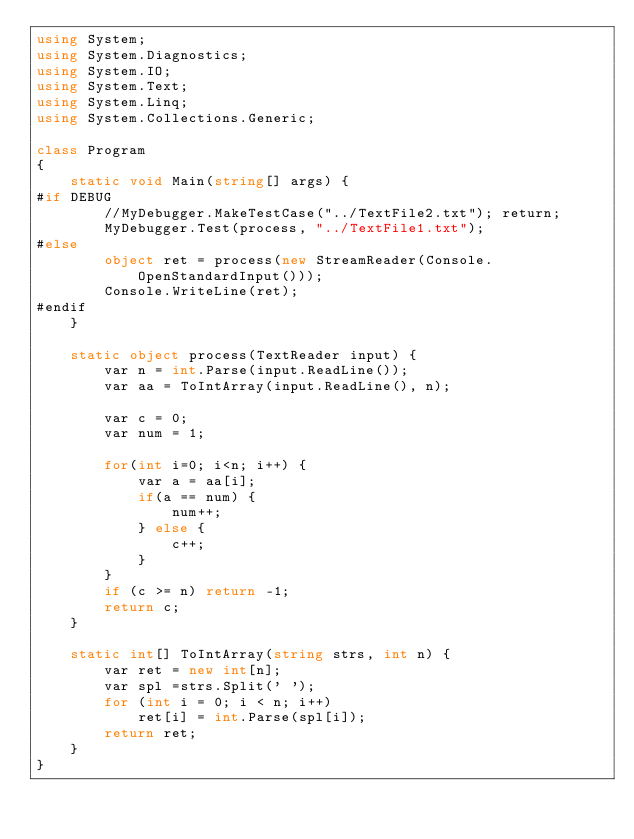<code> <loc_0><loc_0><loc_500><loc_500><_C#_>using System;
using System.Diagnostics;
using System.IO;
using System.Text;
using System.Linq;
using System.Collections.Generic;

class Program
{
    static void Main(string[] args) {
#if DEBUG
        //MyDebugger.MakeTestCase("../TextFile2.txt"); return;
        MyDebugger.Test(process, "../TextFile1.txt");
#else
        object ret = process(new StreamReader(Console.OpenStandardInput()));
        Console.WriteLine(ret);
#endif
    }

    static object process(TextReader input) {
        var n = int.Parse(input.ReadLine());
        var aa = ToIntArray(input.ReadLine(), n);

        var c = 0;
        var num = 1;

        for(int i=0; i<n; i++) {
            var a = aa[i];
            if(a == num) {
                num++;
            } else {
                c++;
            }
        }
        if (c >= n) return -1;
        return c;
    }

    static int[] ToIntArray(string strs, int n) {
        var ret = new int[n];
        var spl =strs.Split(' ');
        for (int i = 0; i < n; i++)
            ret[i] = int.Parse(spl[i]);
        return ret;
    }
}
</code> 